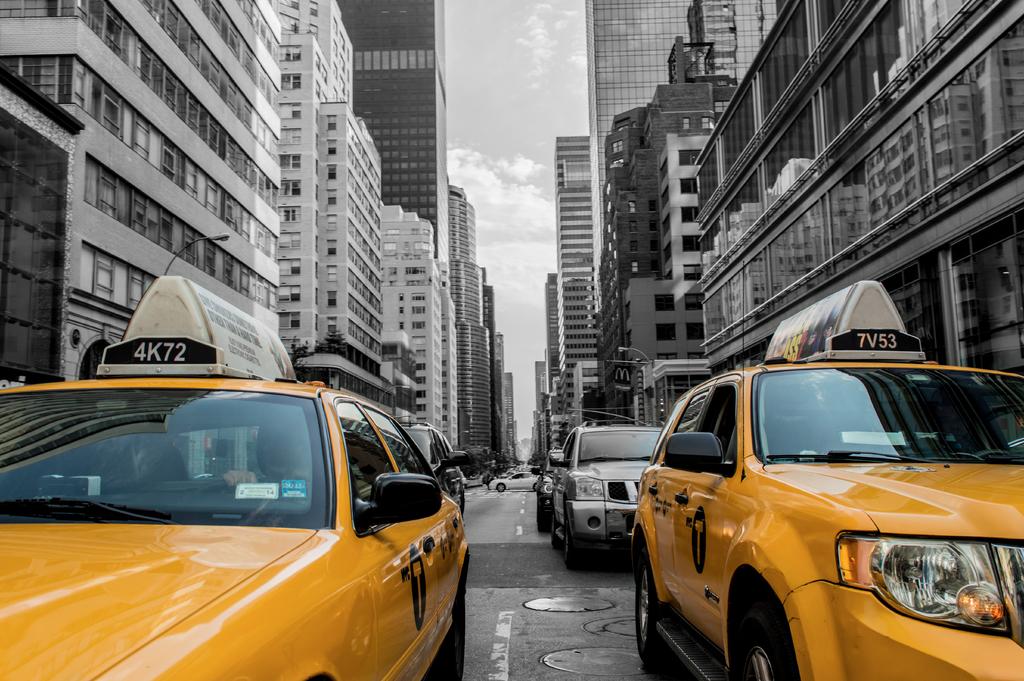What is the number of the taxi on the right?
Offer a terse response. 7v53. What is the number of the taxi on the left?
Make the answer very short. 4k72. 